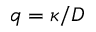Convert formula to latex. <formula><loc_0><loc_0><loc_500><loc_500>q = \kappa / D</formula> 